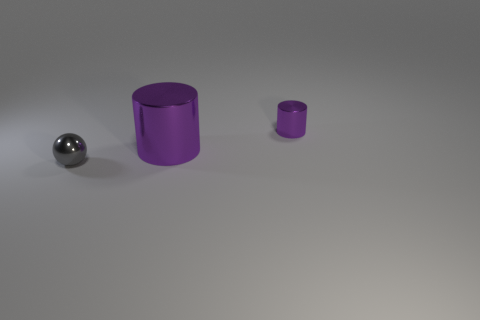What materials do the objects appear to be made of? The large and small cylinders have a matte purple finish that suggests they could be made of plastic or painted metal. The spherical object has a reflective surface that implies it could be metallic. 